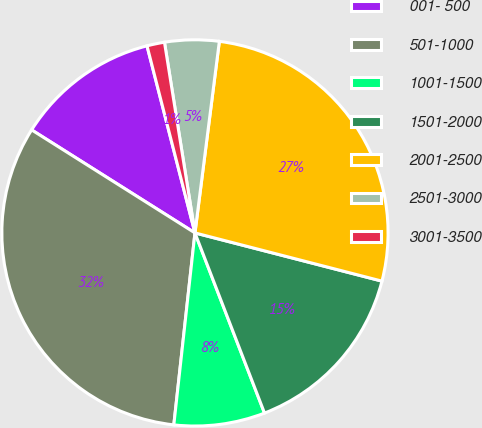Convert chart. <chart><loc_0><loc_0><loc_500><loc_500><pie_chart><fcel>001- 500<fcel>501-1000<fcel>1001-1500<fcel>1501-2000<fcel>2001-2500<fcel>2501-3000<fcel>3001-3500<nl><fcel>12.05%<fcel>32.21%<fcel>7.61%<fcel>15.12%<fcel>27.0%<fcel>4.54%<fcel>1.47%<nl></chart> 